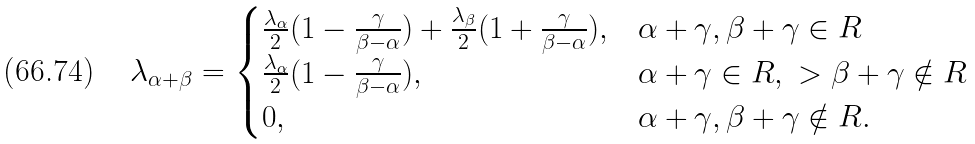<formula> <loc_0><loc_0><loc_500><loc_500>\lambda _ { \alpha + \beta } = \begin{cases} \frac { \lambda _ { \alpha } } { 2 } ( 1 - \frac { \gamma } { \beta - \alpha } ) + \frac { \lambda _ { \beta } } { 2 } ( 1 + \frac { \gamma } { \beta - \alpha } ) , & \alpha + \gamma , \beta + \gamma \in R \\ \frac { \lambda _ { \alpha } } { 2 } ( 1 - \frac { \gamma } { \beta - \alpha } ) , & \alpha + \gamma \in R , \ > \beta + \gamma \notin R \\ 0 , & \alpha + \gamma , \beta + \gamma \notin R . \end{cases}</formula> 